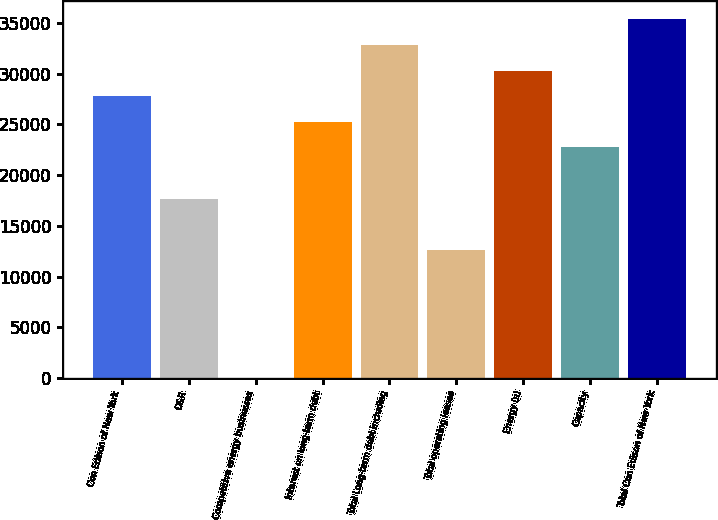Convert chart. <chart><loc_0><loc_0><loc_500><loc_500><bar_chart><fcel>Con Edison of New York<fcel>O&R<fcel>Competitive energy businesses<fcel>Interest on long-term debt<fcel>Total Long-term debt including<fcel>Total operating leases<fcel>Energy (a)<fcel>Capacity<fcel>Total Con Edison of New York<nl><fcel>27784.6<fcel>17682.2<fcel>3<fcel>25259<fcel>32835.8<fcel>12631<fcel>30310.2<fcel>22733.4<fcel>35361.4<nl></chart> 